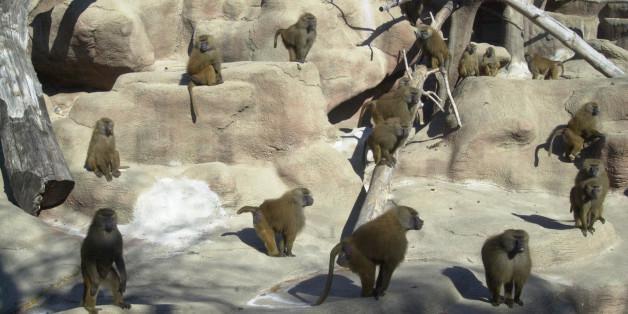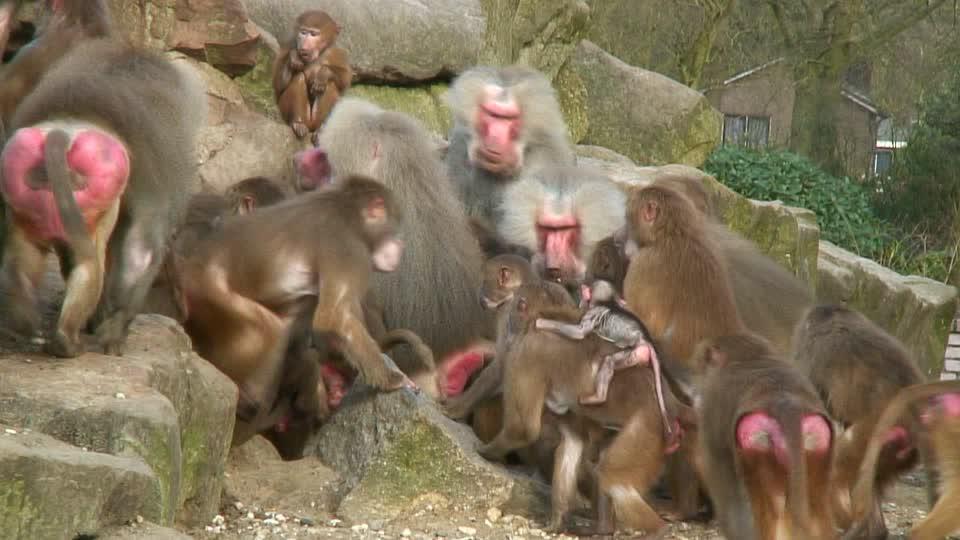The first image is the image on the left, the second image is the image on the right. Given the left and right images, does the statement "A small amount of sky can be seen in the background of the image on the right" hold true? Answer yes or no. No. The first image is the image on the left, the second image is the image on the right. Evaluate the accuracy of this statement regarding the images: "Bulbous pink rear ends of multiple baboons are visible in one image.". Is it true? Answer yes or no. Yes. 